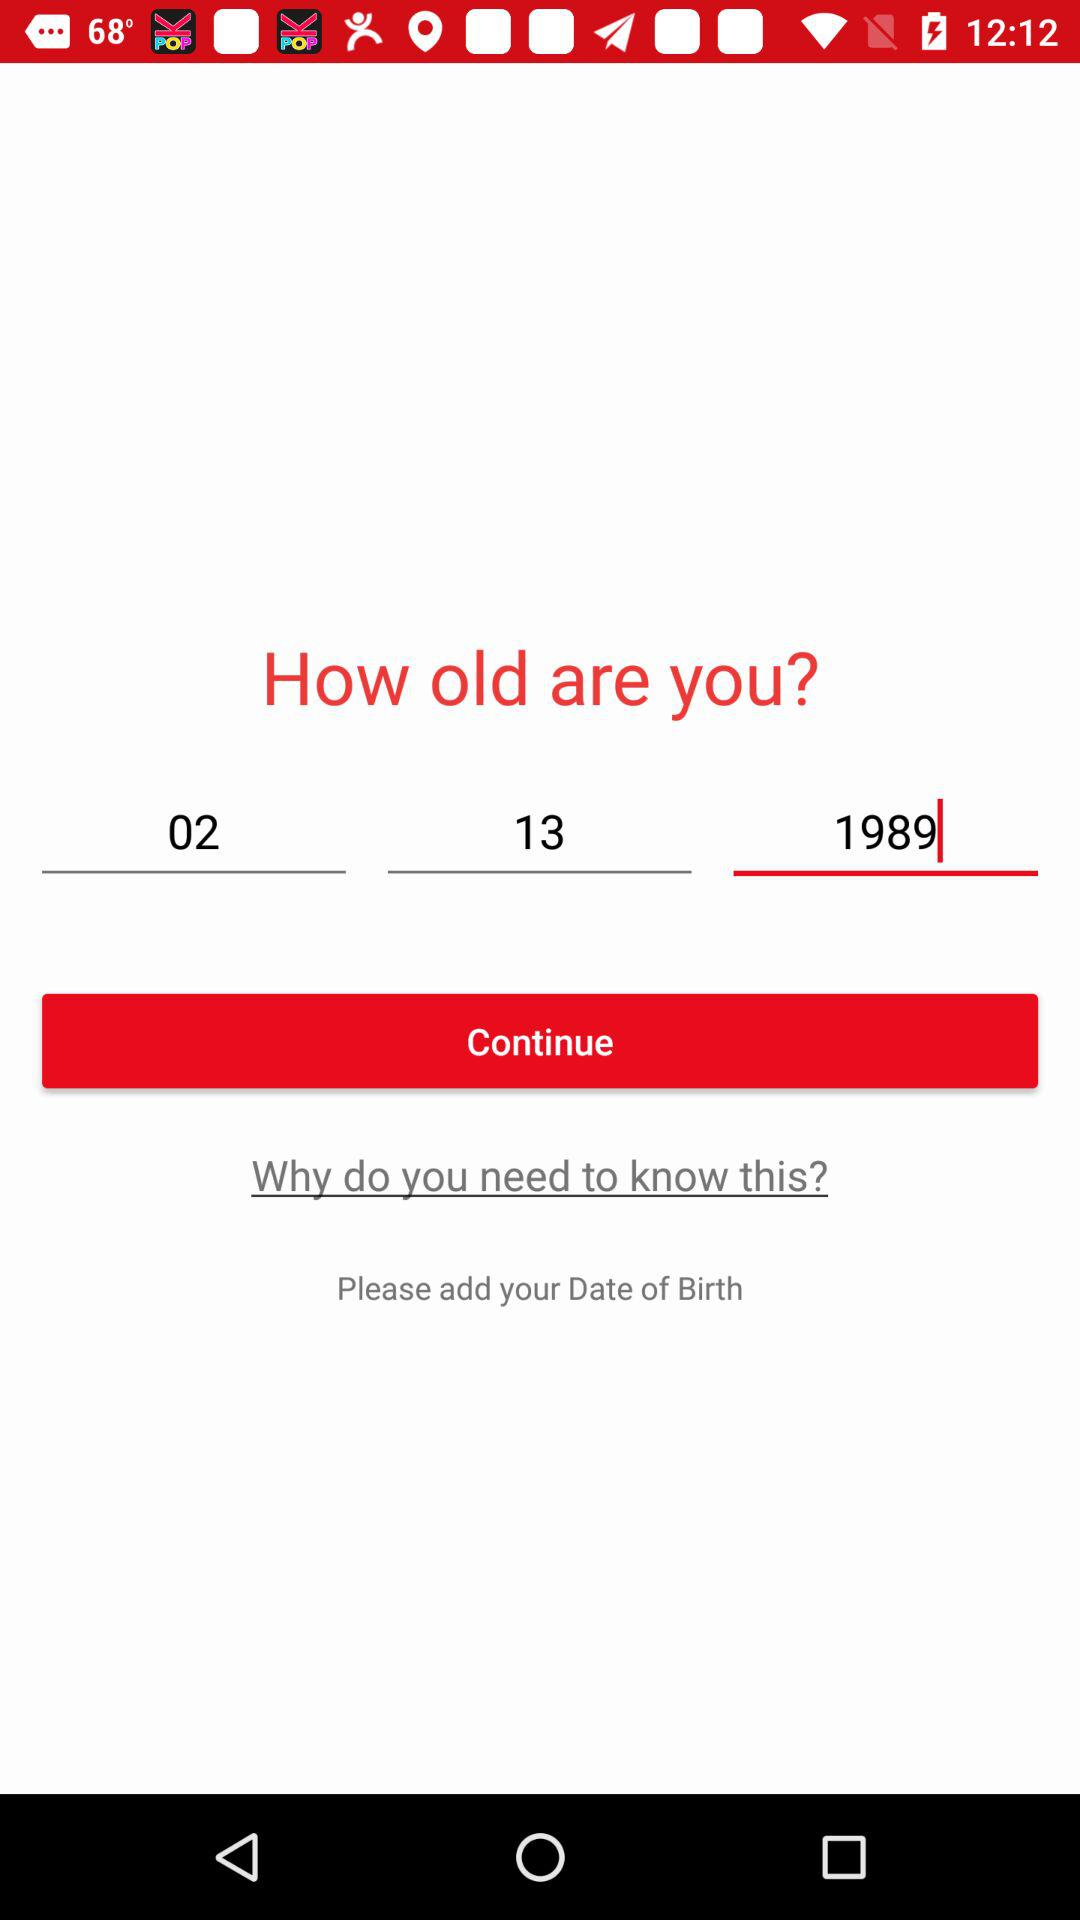What is the selected month? The selected month is February. 